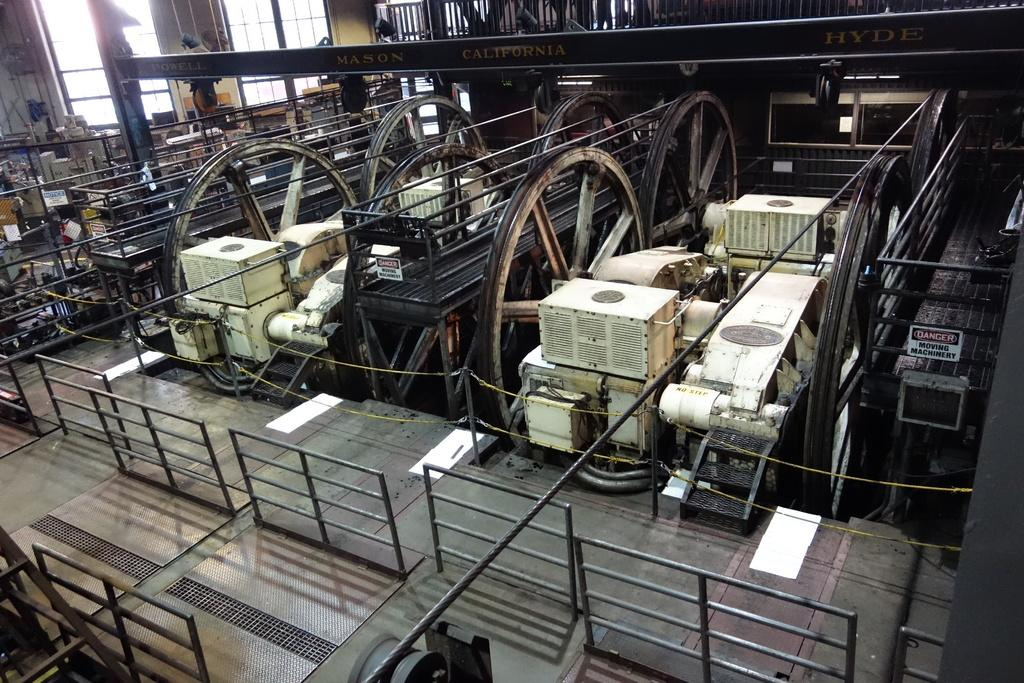What type of objects can be seen in the image? There are machines, boards, ropes, iron rods, and windows in the image. Can you describe the machines in the image? Unfortunately, the facts provided do not give specific details about the machines. What are the boards used for in the image? The facts provided do not give specific details about the purpose of the boards. What are the ropes and iron rods used for in the image? The ropes and iron rods may be used for structural support or to connect different elements in the image. How many windows are visible in the image? The facts provided do not specify the number of windows in the image. Where is the key used to unlock the park gate in the image? There is no park or key present in the image. What type of bath can be seen in the image? There is no bath present in the image. 